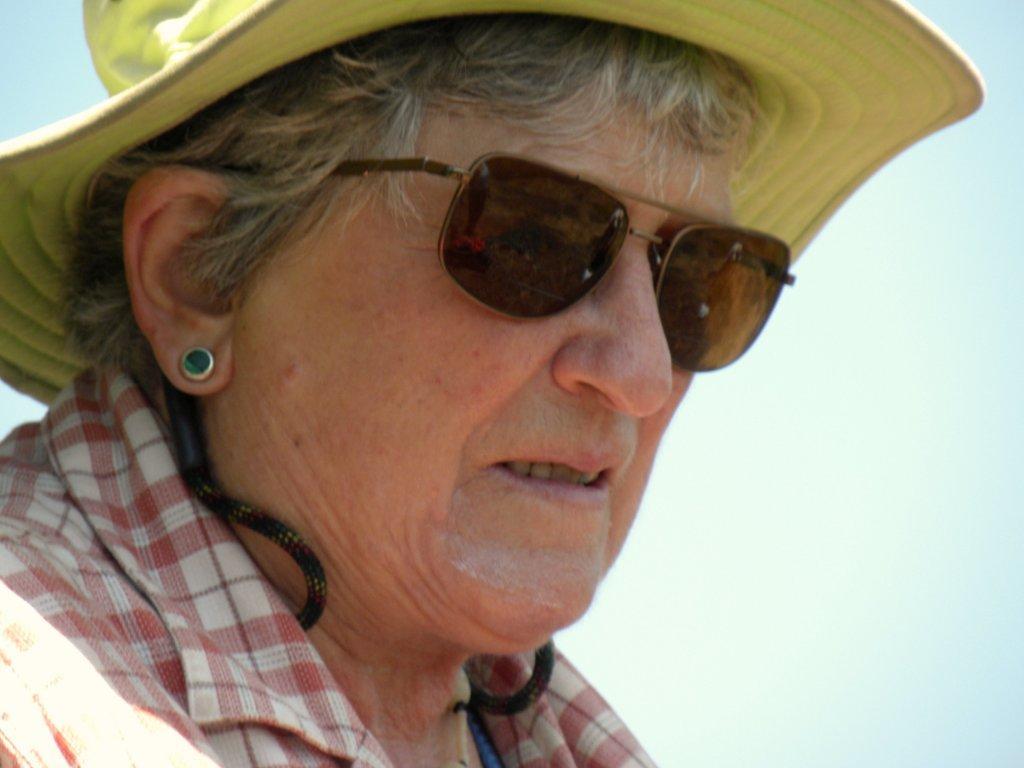Please provide a concise description of this image. In this picture, we see a woman is wearing the red and white check shirt. She is wearing the goggles and a yellow hat. In the background, we see the sky. 